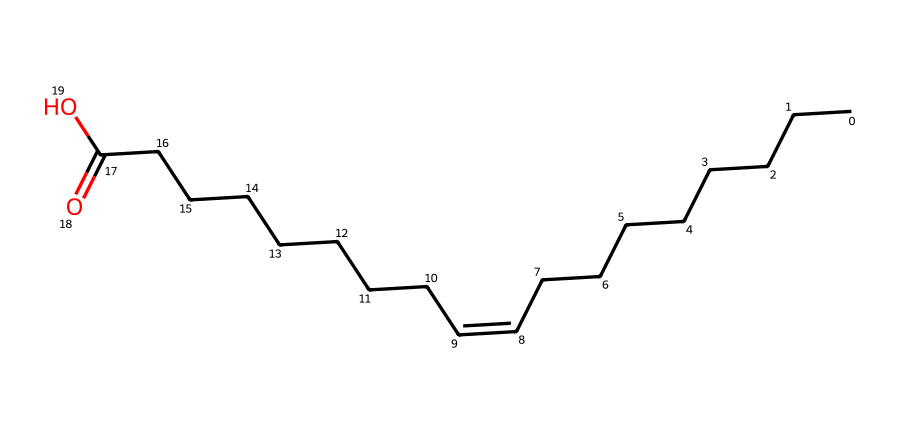What is the number of carbon atoms in oleic acid? By analyzing the SMILES representation, "CCCCCCCC/C=C\CCCCCCCC(=O)O", we can count the carbon atoms in the hydrocarbon chain. The "C" letters represent carbon atoms. There are 18 carbon atoms in total in this structure.
Answer: 18 How many double bonds are present in oleic acid? The SMILES indicates a "/C=C/" section, which suggests there is one double bond present between two carbon atoms in the alkene part of the structure. Therefore, only one double bond exists in oleic acid.
Answer: 1 Is oleic acid saturated or unsaturated? Due to the presence of a double bond (as indicated by the "C=C"), oleic acid is classed as an unsaturated fatty acid, in contrast to saturated fatty acids, which have no double bonds.
Answer: unsaturated What is the functional group present in oleic acid? The "O" and "(=O)O" parts at the end of the SMILES denote the presence of a carboxylic acid functional group (-COOH) in oleic acid. This means that oleic acid contains a carboxylic acid functional group.
Answer: carboxylic acid What type of geometric isomerism can oleic acid exhibit? Oleic acid features a double bond that can create two geometric isomers: cis and trans, based on the spatial arrangement of groups around the double bond. Therefore, it can exhibit cis-trans isomerism.
Answer: cis-trans isomerism How many cis-trans isomers does oleic acid have? The double bond in oleic acid allows for the formation of two distinct configurations: cis (where similar groups are on the same side) and trans (where they are on opposite sides). Thus, oleic acid has two geometric isomers.
Answer: 2 What effect does the geometry have on the melting point of oleic acid? The cis configuration causes bending in the fatty acid chain, preventing tight packing and leading to a lower melting point compared to the trans isomer, which allows for more linear packing and higher melting points.
Answer: lower melting point 